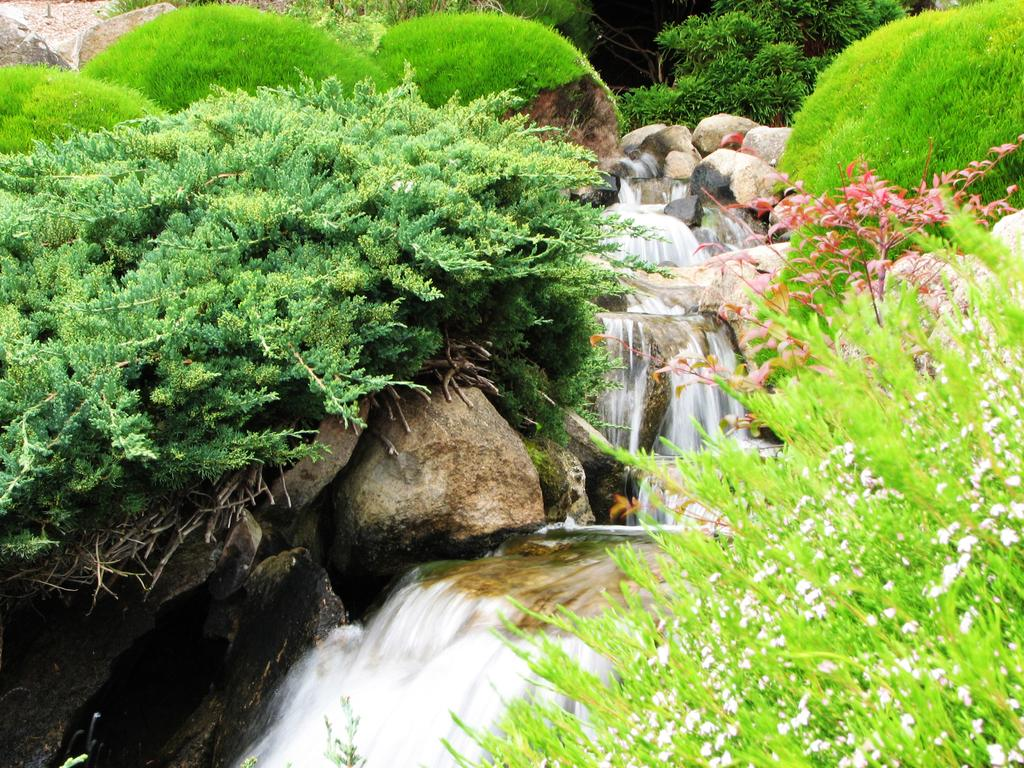What type of vegetation can be seen in the image? There are plants and grass in the image. What other elements can be found in the image? There are stones and a waterfall in the image. What type of cake is being served at the sister's brass party in the image? There is no mention of a sister, brass, or cake in the image. The image features plants, grass, stones, and a waterfall. 